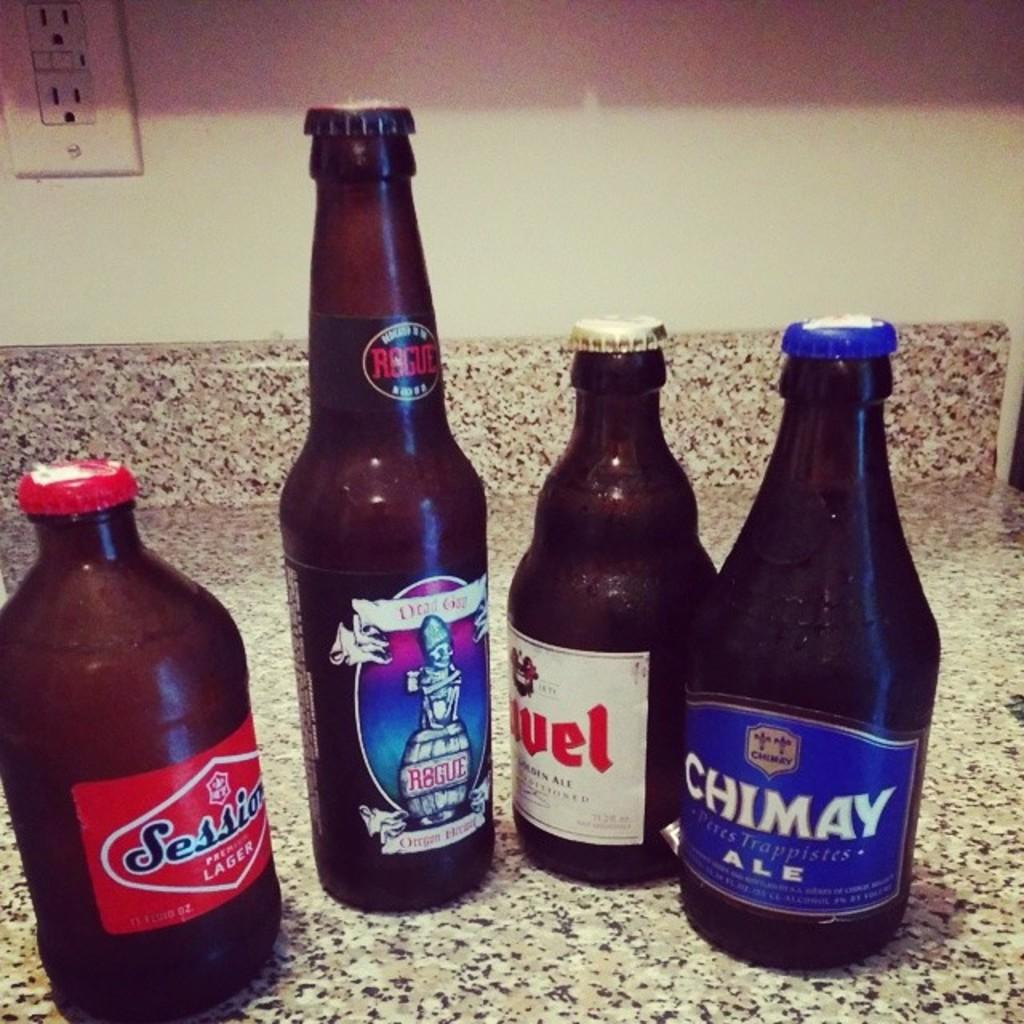What type of bottles can be seen on the floor in the image? There are beer bottles on the floor in the image. Can you describe any other objects or features in the image? Yes, there is a socket on the top left side of the image. What type of bulb is hanging from the socket in the image? There is no bulb present in the image; only a socket can be seen on the top left side. 